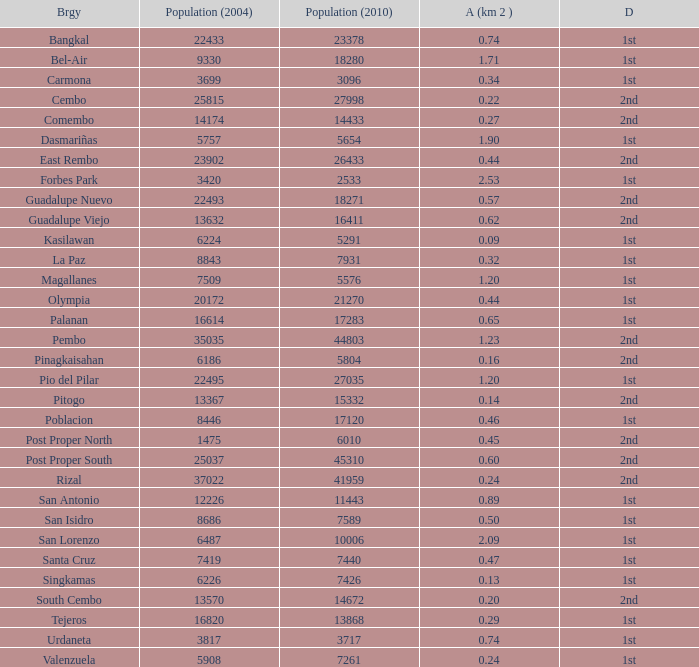What is the area where barangay is guadalupe viejo? 0.62. 